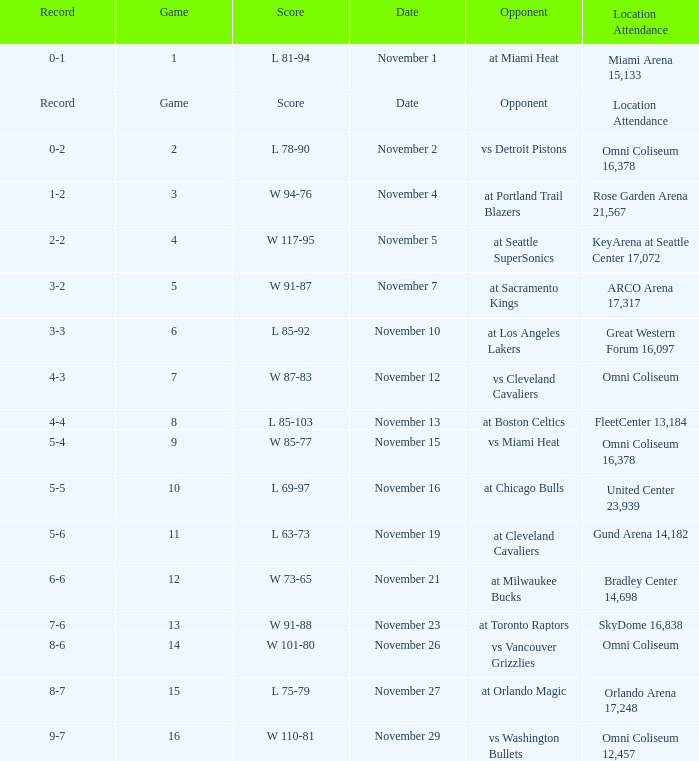On what date was game 3? November 4. 